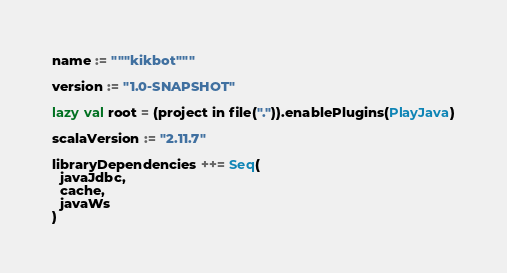<code> <loc_0><loc_0><loc_500><loc_500><_Scala_>name := """kikbot"""

version := "1.0-SNAPSHOT"

lazy val root = (project in file(".")).enablePlugins(PlayJava)

scalaVersion := "2.11.7"

libraryDependencies ++= Seq(
  javaJdbc,
  cache,
  javaWs
)
</code> 